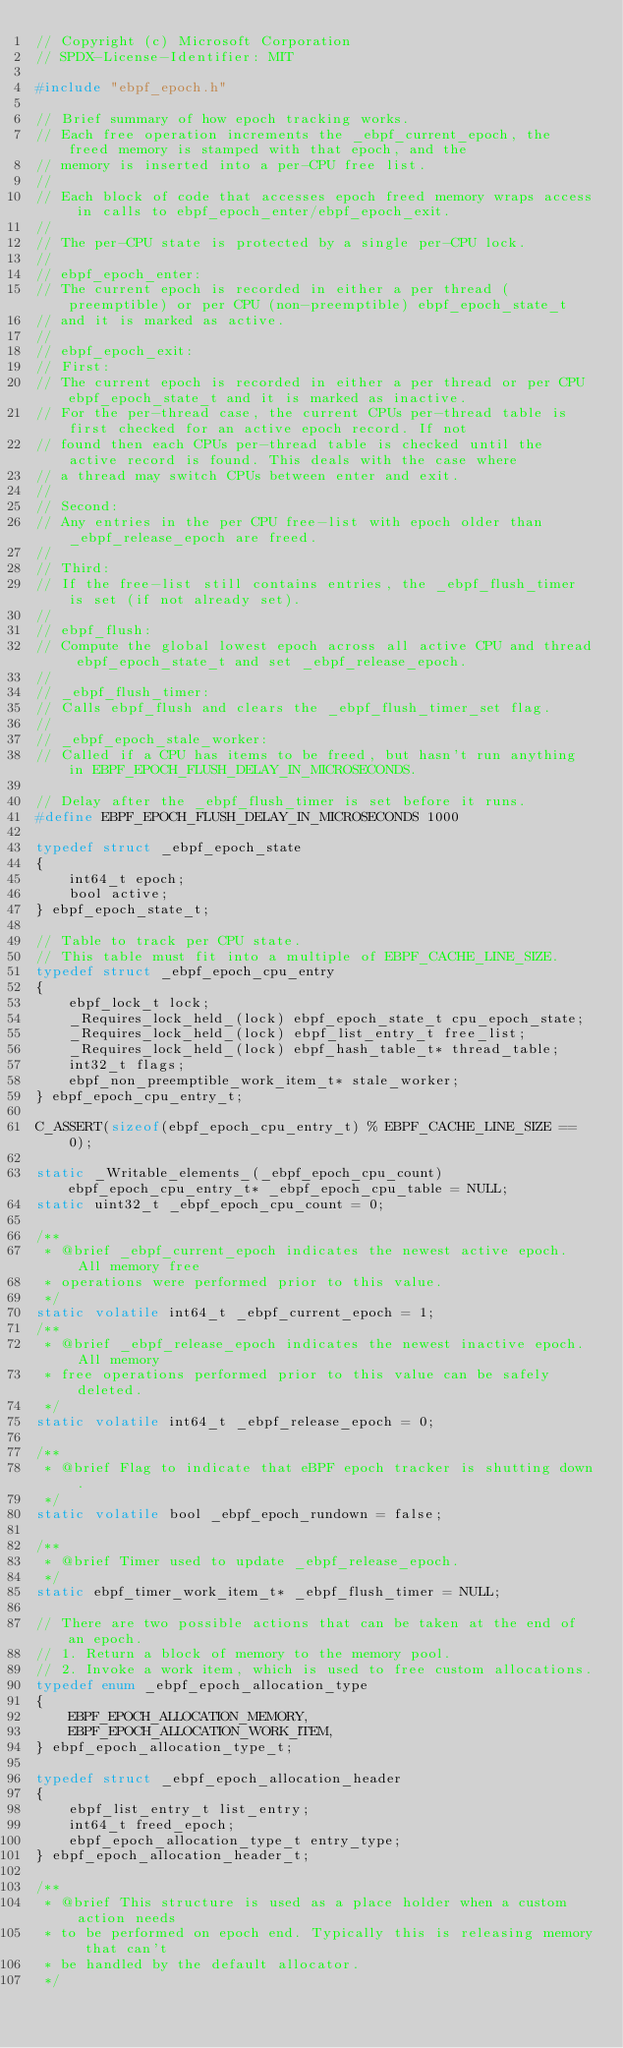<code> <loc_0><loc_0><loc_500><loc_500><_C_>// Copyright (c) Microsoft Corporation
// SPDX-License-Identifier: MIT

#include "ebpf_epoch.h"

// Brief summary of how epoch tracking works.
// Each free operation increments the _ebpf_current_epoch, the freed memory is stamped with that epoch, and the
// memory is inserted into a per-CPU free list.
//
// Each block of code that accesses epoch freed memory wraps access in calls to ebpf_epoch_enter/ebpf_epoch_exit.
//
// The per-CPU state is protected by a single per-CPU lock.
//
// ebpf_epoch_enter:
// The current epoch is recorded in either a per thread (preemptible) or per CPU (non-preemptible) ebpf_epoch_state_t
// and it is marked as active.
//
// ebpf_epoch_exit:
// First:
// The current epoch is recorded in either a per thread or per CPU ebpf_epoch_state_t and it is marked as inactive.
// For the per-thread case, the current CPUs per-thread table is first checked for an active epoch record. If not
// found then each CPUs per-thread table is checked until the active record is found. This deals with the case where
// a thread may switch CPUs between enter and exit.
//
// Second:
// Any entries in the per CPU free-list with epoch older than _ebpf_release_epoch are freed.
//
// Third:
// If the free-list still contains entries, the _ebpf_flush_timer is set (if not already set).
//
// ebpf_flush:
// Compute the global lowest epoch across all active CPU and thread ebpf_epoch_state_t and set _ebpf_release_epoch.
//
// _ebpf_flush_timer:
// Calls ebpf_flush and clears the _ebpf_flush_timer_set flag.
//
// _ebpf_epoch_stale_worker:
// Called if a CPU has items to be freed, but hasn't run anything in EBPF_EPOCH_FLUSH_DELAY_IN_MICROSECONDS.

// Delay after the _ebpf_flush_timer is set before it runs.
#define EBPF_EPOCH_FLUSH_DELAY_IN_MICROSECONDS 1000

typedef struct _ebpf_epoch_state
{
    int64_t epoch;
    bool active;
} ebpf_epoch_state_t;

// Table to track per CPU state.
// This table must fit into a multiple of EBPF_CACHE_LINE_SIZE.
typedef struct _ebpf_epoch_cpu_entry
{
    ebpf_lock_t lock;
    _Requires_lock_held_(lock) ebpf_epoch_state_t cpu_epoch_state;
    _Requires_lock_held_(lock) ebpf_list_entry_t free_list;
    _Requires_lock_held_(lock) ebpf_hash_table_t* thread_table;
    int32_t flags;
    ebpf_non_preemptible_work_item_t* stale_worker;
} ebpf_epoch_cpu_entry_t;

C_ASSERT(sizeof(ebpf_epoch_cpu_entry_t) % EBPF_CACHE_LINE_SIZE == 0);

static _Writable_elements_(_ebpf_epoch_cpu_count) ebpf_epoch_cpu_entry_t* _ebpf_epoch_cpu_table = NULL;
static uint32_t _ebpf_epoch_cpu_count = 0;

/**
 * @brief _ebpf_current_epoch indicates the newest active epoch. All memory free
 * operations were performed prior to this value.
 */
static volatile int64_t _ebpf_current_epoch = 1;
/**
 * @brief _ebpf_release_epoch indicates the newest inactive epoch. All memory
 * free operations performed prior to this value can be safely deleted.
 */
static volatile int64_t _ebpf_release_epoch = 0;

/**
 * @brief Flag to indicate that eBPF epoch tracker is shutting down.
 */
static volatile bool _ebpf_epoch_rundown = false;

/**
 * @brief Timer used to update _ebpf_release_epoch.
 */
static ebpf_timer_work_item_t* _ebpf_flush_timer = NULL;

// There are two possible actions that can be taken at the end of an epoch.
// 1. Return a block of memory to the memory pool.
// 2. Invoke a work item, which is used to free custom allocations.
typedef enum _ebpf_epoch_allocation_type
{
    EBPF_EPOCH_ALLOCATION_MEMORY,
    EBPF_EPOCH_ALLOCATION_WORK_ITEM,
} ebpf_epoch_allocation_type_t;

typedef struct _ebpf_epoch_allocation_header
{
    ebpf_list_entry_t list_entry;
    int64_t freed_epoch;
    ebpf_epoch_allocation_type_t entry_type;
} ebpf_epoch_allocation_header_t;

/**
 * @brief This structure is used as a place holder when a custom action needs
 * to be performed on epoch end. Typically this is releasing memory that can't
 * be handled by the default allocator.
 */</code> 